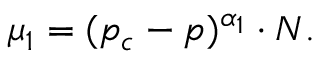<formula> <loc_0><loc_0><loc_500><loc_500>\begin{array} { r } { \mu _ { 1 } = ( p _ { c } - p ) ^ { \alpha _ { 1 } } \cdot N . } \end{array}</formula> 